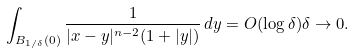<formula> <loc_0><loc_0><loc_500><loc_500>\int _ { B _ { 1 / \delta } ( 0 ) } \frac { 1 } { | x - y | ^ { n - 2 } ( 1 + | y | ) } \, d y = O ( \log \delta ) \delta \to 0 .</formula> 